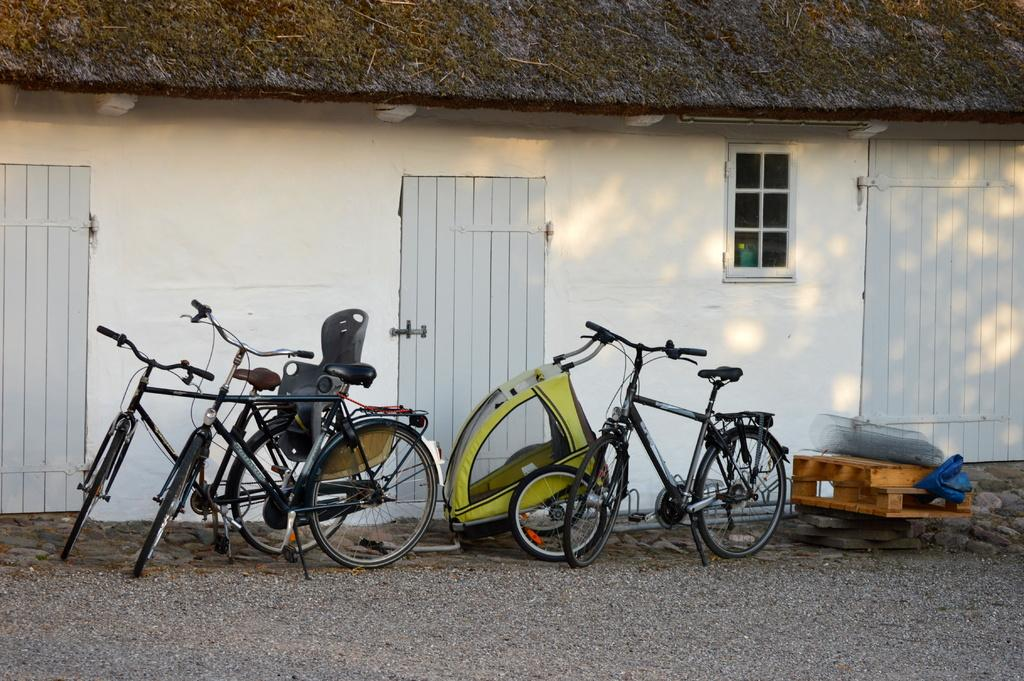What type of vehicles are in the image? There are bicycles in the image. What type of structure is in the image? There is a building in the image. What architectural features can be seen in the image? There are windows and doors in the image. What other objects are present in the image? There are other objects in the image. What is the color of the object on the ground? There is a brown color object on the ground. Can you see the wings of the bicycles in the image? There are no wings on the bicycles in the image. What system is responsible for the movement of the objects in the image? The image does not depict a system responsible for the movement of objects; it is a still image. 